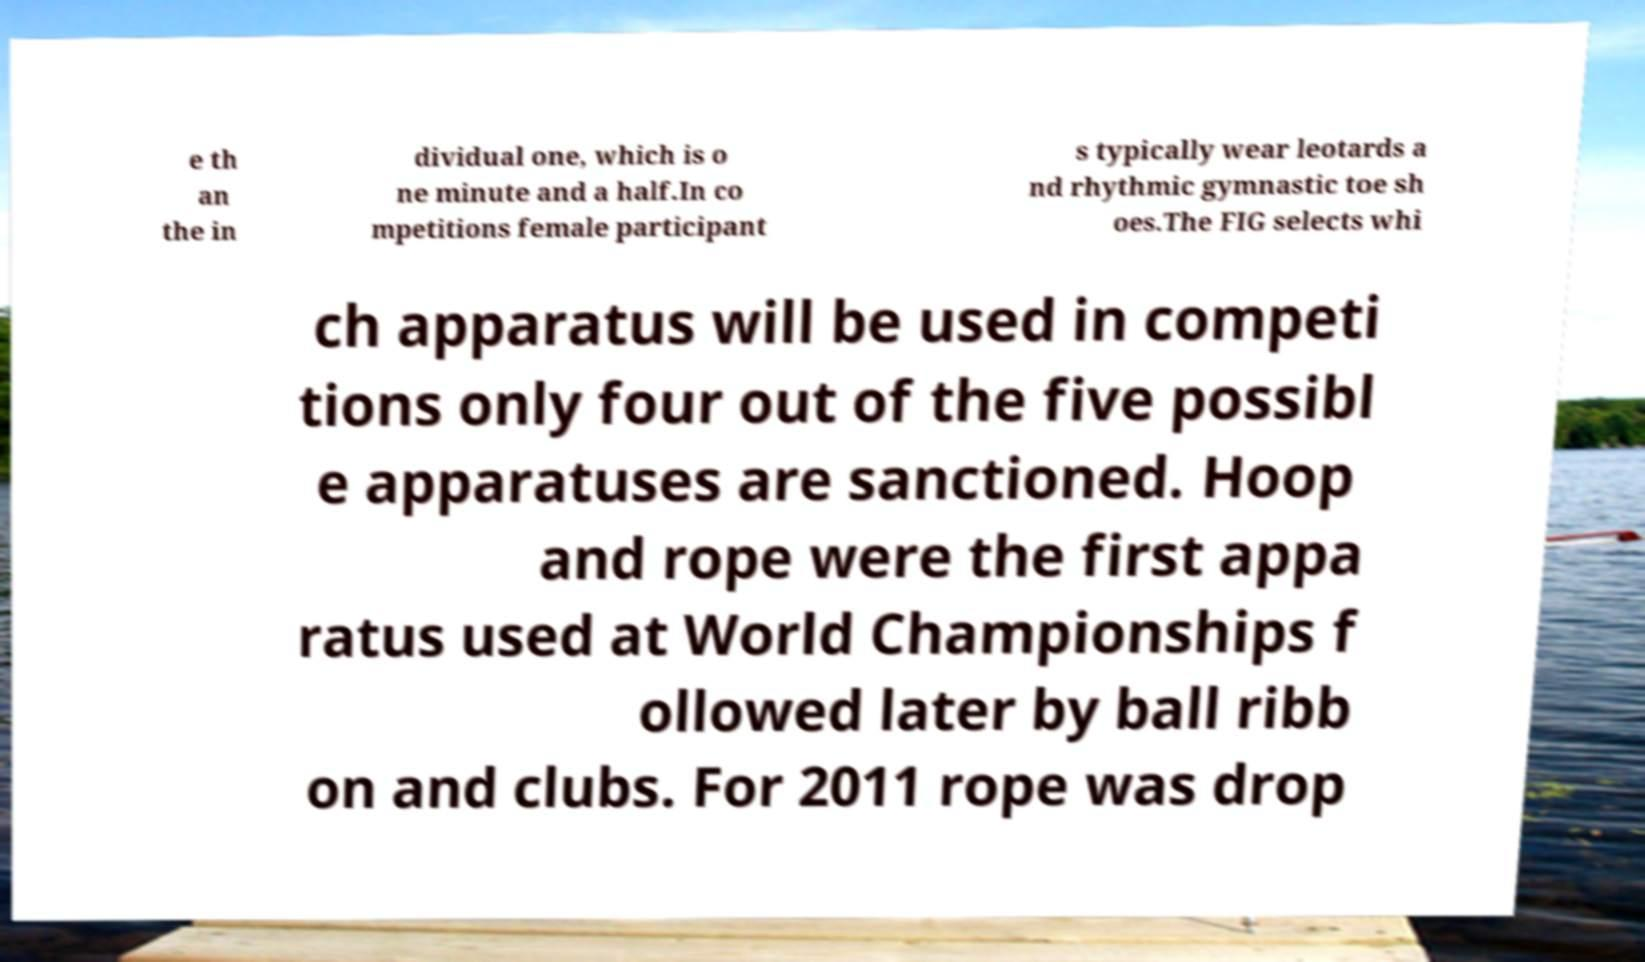Please identify and transcribe the text found in this image. e th an the in dividual one, which is o ne minute and a half.In co mpetitions female participant s typically wear leotards a nd rhythmic gymnastic toe sh oes.The FIG selects whi ch apparatus will be used in competi tions only four out of the five possibl e apparatuses are sanctioned. Hoop and rope were the first appa ratus used at World Championships f ollowed later by ball ribb on and clubs. For 2011 rope was drop 